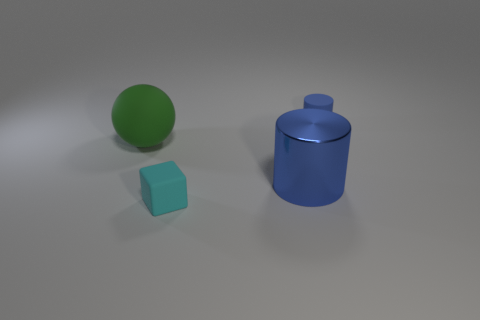Is the size of the blue cylinder on the left side of the blue rubber thing the same as the thing that is behind the large green rubber object?
Your answer should be compact. No. There is a object that is behind the big shiny thing and to the right of the green matte sphere; what is it made of?
Keep it short and to the point. Rubber. What number of blue matte things are in front of the tiny matte block?
Your answer should be very brief. 0. Is there any other thing that is the same size as the ball?
Keep it short and to the point. Yes. There is a cube that is the same material as the large green sphere; what is its color?
Your answer should be very brief. Cyan. Is the shape of the blue rubber thing the same as the large metal thing?
Give a very brief answer. Yes. How many objects are behind the blue shiny thing and to the right of the small matte cube?
Make the answer very short. 1. What number of metallic things are red blocks or large green objects?
Offer a terse response. 0. What is the size of the blue thing in front of the tiny object behind the big green ball?
Your response must be concise. Large. There is a small cylinder that is the same color as the big cylinder; what is it made of?
Your response must be concise. Rubber. 